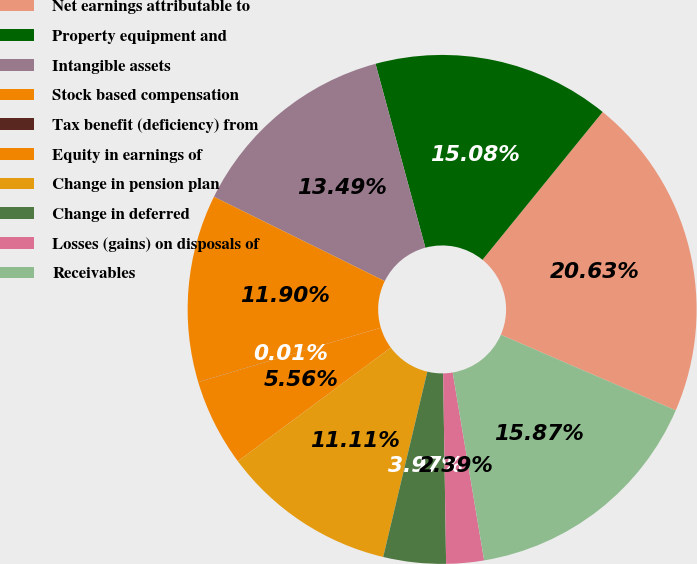Convert chart. <chart><loc_0><loc_0><loc_500><loc_500><pie_chart><fcel>Net earnings attributable to<fcel>Property equipment and<fcel>Intangible assets<fcel>Stock based compensation<fcel>Tax benefit (deficiency) from<fcel>Equity in earnings of<fcel>Change in pension plan<fcel>Change in deferred<fcel>Losses (gains) on disposals of<fcel>Receivables<nl><fcel>20.63%<fcel>15.08%<fcel>13.49%<fcel>11.9%<fcel>0.01%<fcel>5.56%<fcel>11.11%<fcel>3.97%<fcel>2.39%<fcel>15.87%<nl></chart> 